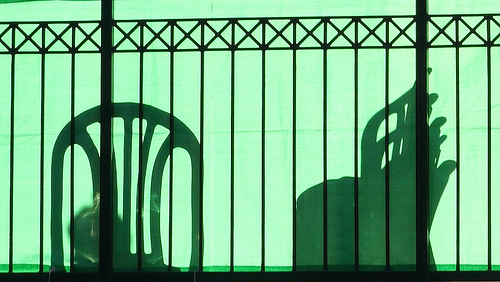<image>
Can you confirm if the chair shadow is to the left of the fence? No. The chair shadow is not to the left of the fence. From this viewpoint, they have a different horizontal relationship. 